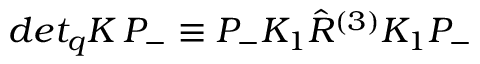Convert formula to latex. <formula><loc_0><loc_0><loc_500><loc_500>d e t _ { q } K \, P _ { - } \equiv P _ { - } K _ { 1 } \hat { R } ^ { ( 3 ) } K _ { 1 } P _ { - }</formula> 